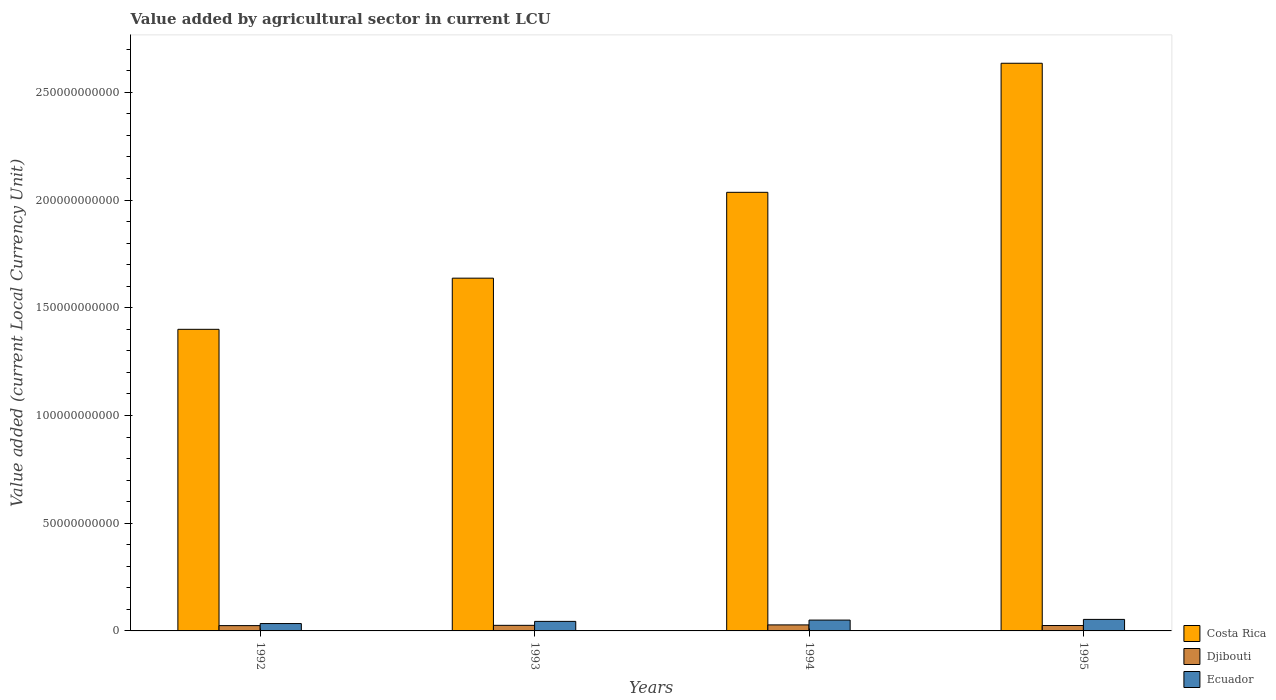Are the number of bars per tick equal to the number of legend labels?
Make the answer very short. Yes. How many bars are there on the 4th tick from the left?
Give a very brief answer. 3. How many bars are there on the 3rd tick from the right?
Provide a succinct answer. 3. What is the label of the 4th group of bars from the left?
Your answer should be very brief. 1995. In how many cases, is the number of bars for a given year not equal to the number of legend labels?
Provide a short and direct response. 0. What is the value added by agricultural sector in Costa Rica in 1994?
Provide a short and direct response. 2.04e+11. Across all years, what is the maximum value added by agricultural sector in Costa Rica?
Make the answer very short. 2.63e+11. Across all years, what is the minimum value added by agricultural sector in Djibouti?
Provide a short and direct response. 2.46e+09. What is the total value added by agricultural sector in Ecuador in the graph?
Make the answer very short. 1.82e+1. What is the difference between the value added by agricultural sector in Costa Rica in 1993 and that in 1995?
Your response must be concise. -9.97e+1. What is the difference between the value added by agricultural sector in Ecuador in 1994 and the value added by agricultural sector in Djibouti in 1995?
Give a very brief answer. 2.52e+09. What is the average value added by agricultural sector in Ecuador per year?
Provide a succinct answer. 4.56e+09. In the year 1993, what is the difference between the value added by agricultural sector in Ecuador and value added by agricultural sector in Djibouti?
Your answer should be compact. 1.83e+09. In how many years, is the value added by agricultural sector in Ecuador greater than 10000000000 LCU?
Offer a terse response. 0. What is the ratio of the value added by agricultural sector in Ecuador in 1993 to that in 1995?
Ensure brevity in your answer.  0.83. Is the difference between the value added by agricultural sector in Ecuador in 1993 and 1995 greater than the difference between the value added by agricultural sector in Djibouti in 1993 and 1995?
Your response must be concise. No. What is the difference between the highest and the second highest value added by agricultural sector in Djibouti?
Offer a very short reply. 1.97e+08. What is the difference between the highest and the lowest value added by agricultural sector in Djibouti?
Give a very brief answer. 3.34e+08. In how many years, is the value added by agricultural sector in Ecuador greater than the average value added by agricultural sector in Ecuador taken over all years?
Give a very brief answer. 2. Is the sum of the value added by agricultural sector in Costa Rica in 1993 and 1994 greater than the maximum value added by agricultural sector in Djibouti across all years?
Your answer should be very brief. Yes. What does the 2nd bar from the left in 1995 represents?
Your response must be concise. Djibouti. What does the 2nd bar from the right in 1994 represents?
Offer a very short reply. Djibouti. Does the graph contain any zero values?
Your response must be concise. No. Does the graph contain grids?
Provide a short and direct response. No. Where does the legend appear in the graph?
Your answer should be very brief. Bottom right. What is the title of the graph?
Offer a terse response. Value added by agricultural sector in current LCU. Does "Tanzania" appear as one of the legend labels in the graph?
Make the answer very short. No. What is the label or title of the X-axis?
Your response must be concise. Years. What is the label or title of the Y-axis?
Make the answer very short. Value added (current Local Currency Unit). What is the Value added (current Local Currency Unit) in Costa Rica in 1992?
Offer a terse response. 1.40e+11. What is the Value added (current Local Currency Unit) in Djibouti in 1992?
Offer a terse response. 2.46e+09. What is the Value added (current Local Currency Unit) in Ecuador in 1992?
Ensure brevity in your answer.  3.42e+09. What is the Value added (current Local Currency Unit) in Costa Rica in 1993?
Make the answer very short. 1.64e+11. What is the Value added (current Local Currency Unit) in Djibouti in 1993?
Your response must be concise. 2.60e+09. What is the Value added (current Local Currency Unit) in Ecuador in 1993?
Keep it short and to the point. 4.43e+09. What is the Value added (current Local Currency Unit) in Costa Rica in 1994?
Offer a terse response. 2.04e+11. What is the Value added (current Local Currency Unit) in Djibouti in 1994?
Make the answer very short. 2.79e+09. What is the Value added (current Local Currency Unit) in Ecuador in 1994?
Make the answer very short. 5.03e+09. What is the Value added (current Local Currency Unit) of Costa Rica in 1995?
Provide a succinct answer. 2.63e+11. What is the Value added (current Local Currency Unit) of Djibouti in 1995?
Provide a short and direct response. 2.51e+09. What is the Value added (current Local Currency Unit) in Ecuador in 1995?
Your response must be concise. 5.35e+09. Across all years, what is the maximum Value added (current Local Currency Unit) of Costa Rica?
Your answer should be very brief. 2.63e+11. Across all years, what is the maximum Value added (current Local Currency Unit) in Djibouti?
Keep it short and to the point. 2.79e+09. Across all years, what is the maximum Value added (current Local Currency Unit) in Ecuador?
Offer a terse response. 5.35e+09. Across all years, what is the minimum Value added (current Local Currency Unit) in Costa Rica?
Your answer should be compact. 1.40e+11. Across all years, what is the minimum Value added (current Local Currency Unit) in Djibouti?
Provide a short and direct response. 2.46e+09. Across all years, what is the minimum Value added (current Local Currency Unit) in Ecuador?
Provide a succinct answer. 3.42e+09. What is the total Value added (current Local Currency Unit) of Costa Rica in the graph?
Your response must be concise. 7.71e+11. What is the total Value added (current Local Currency Unit) of Djibouti in the graph?
Provide a short and direct response. 1.04e+1. What is the total Value added (current Local Currency Unit) of Ecuador in the graph?
Your answer should be compact. 1.82e+1. What is the difference between the Value added (current Local Currency Unit) in Costa Rica in 1992 and that in 1993?
Your response must be concise. -2.37e+1. What is the difference between the Value added (current Local Currency Unit) in Djibouti in 1992 and that in 1993?
Offer a very short reply. -1.36e+08. What is the difference between the Value added (current Local Currency Unit) in Ecuador in 1992 and that in 1993?
Provide a short and direct response. -1.01e+09. What is the difference between the Value added (current Local Currency Unit) of Costa Rica in 1992 and that in 1994?
Your response must be concise. -6.36e+1. What is the difference between the Value added (current Local Currency Unit) in Djibouti in 1992 and that in 1994?
Your answer should be compact. -3.34e+08. What is the difference between the Value added (current Local Currency Unit) of Ecuador in 1992 and that in 1994?
Ensure brevity in your answer.  -1.60e+09. What is the difference between the Value added (current Local Currency Unit) in Costa Rica in 1992 and that in 1995?
Provide a succinct answer. -1.23e+11. What is the difference between the Value added (current Local Currency Unit) of Djibouti in 1992 and that in 1995?
Provide a short and direct response. -4.76e+07. What is the difference between the Value added (current Local Currency Unit) of Ecuador in 1992 and that in 1995?
Ensure brevity in your answer.  -1.93e+09. What is the difference between the Value added (current Local Currency Unit) of Costa Rica in 1993 and that in 1994?
Provide a short and direct response. -3.98e+1. What is the difference between the Value added (current Local Currency Unit) in Djibouti in 1993 and that in 1994?
Your answer should be compact. -1.97e+08. What is the difference between the Value added (current Local Currency Unit) of Ecuador in 1993 and that in 1994?
Ensure brevity in your answer.  -5.96e+08. What is the difference between the Value added (current Local Currency Unit) in Costa Rica in 1993 and that in 1995?
Provide a short and direct response. -9.97e+1. What is the difference between the Value added (current Local Currency Unit) of Djibouti in 1993 and that in 1995?
Offer a terse response. 8.87e+07. What is the difference between the Value added (current Local Currency Unit) in Ecuador in 1993 and that in 1995?
Your answer should be very brief. -9.21e+08. What is the difference between the Value added (current Local Currency Unit) of Costa Rica in 1994 and that in 1995?
Your answer should be very brief. -5.99e+1. What is the difference between the Value added (current Local Currency Unit) of Djibouti in 1994 and that in 1995?
Provide a short and direct response. 2.86e+08. What is the difference between the Value added (current Local Currency Unit) in Ecuador in 1994 and that in 1995?
Your response must be concise. -3.25e+08. What is the difference between the Value added (current Local Currency Unit) in Costa Rica in 1992 and the Value added (current Local Currency Unit) in Djibouti in 1993?
Give a very brief answer. 1.37e+11. What is the difference between the Value added (current Local Currency Unit) of Costa Rica in 1992 and the Value added (current Local Currency Unit) of Ecuador in 1993?
Offer a very short reply. 1.36e+11. What is the difference between the Value added (current Local Currency Unit) of Djibouti in 1992 and the Value added (current Local Currency Unit) of Ecuador in 1993?
Your response must be concise. -1.97e+09. What is the difference between the Value added (current Local Currency Unit) in Costa Rica in 1992 and the Value added (current Local Currency Unit) in Djibouti in 1994?
Your response must be concise. 1.37e+11. What is the difference between the Value added (current Local Currency Unit) in Costa Rica in 1992 and the Value added (current Local Currency Unit) in Ecuador in 1994?
Your response must be concise. 1.35e+11. What is the difference between the Value added (current Local Currency Unit) in Djibouti in 1992 and the Value added (current Local Currency Unit) in Ecuador in 1994?
Your response must be concise. -2.57e+09. What is the difference between the Value added (current Local Currency Unit) of Costa Rica in 1992 and the Value added (current Local Currency Unit) of Djibouti in 1995?
Your answer should be compact. 1.37e+11. What is the difference between the Value added (current Local Currency Unit) of Costa Rica in 1992 and the Value added (current Local Currency Unit) of Ecuador in 1995?
Offer a terse response. 1.35e+11. What is the difference between the Value added (current Local Currency Unit) of Djibouti in 1992 and the Value added (current Local Currency Unit) of Ecuador in 1995?
Make the answer very short. -2.89e+09. What is the difference between the Value added (current Local Currency Unit) in Costa Rica in 1993 and the Value added (current Local Currency Unit) in Djibouti in 1994?
Give a very brief answer. 1.61e+11. What is the difference between the Value added (current Local Currency Unit) of Costa Rica in 1993 and the Value added (current Local Currency Unit) of Ecuador in 1994?
Offer a terse response. 1.59e+11. What is the difference between the Value added (current Local Currency Unit) of Djibouti in 1993 and the Value added (current Local Currency Unit) of Ecuador in 1994?
Give a very brief answer. -2.43e+09. What is the difference between the Value added (current Local Currency Unit) of Costa Rica in 1993 and the Value added (current Local Currency Unit) of Djibouti in 1995?
Ensure brevity in your answer.  1.61e+11. What is the difference between the Value added (current Local Currency Unit) in Costa Rica in 1993 and the Value added (current Local Currency Unit) in Ecuador in 1995?
Offer a terse response. 1.58e+11. What is the difference between the Value added (current Local Currency Unit) in Djibouti in 1993 and the Value added (current Local Currency Unit) in Ecuador in 1995?
Provide a succinct answer. -2.76e+09. What is the difference between the Value added (current Local Currency Unit) of Costa Rica in 1994 and the Value added (current Local Currency Unit) of Djibouti in 1995?
Offer a terse response. 2.01e+11. What is the difference between the Value added (current Local Currency Unit) of Costa Rica in 1994 and the Value added (current Local Currency Unit) of Ecuador in 1995?
Provide a short and direct response. 1.98e+11. What is the difference between the Value added (current Local Currency Unit) in Djibouti in 1994 and the Value added (current Local Currency Unit) in Ecuador in 1995?
Offer a terse response. -2.56e+09. What is the average Value added (current Local Currency Unit) in Costa Rica per year?
Provide a short and direct response. 1.93e+11. What is the average Value added (current Local Currency Unit) in Djibouti per year?
Your answer should be very brief. 2.59e+09. What is the average Value added (current Local Currency Unit) of Ecuador per year?
Give a very brief answer. 4.56e+09. In the year 1992, what is the difference between the Value added (current Local Currency Unit) of Costa Rica and Value added (current Local Currency Unit) of Djibouti?
Your answer should be compact. 1.38e+11. In the year 1992, what is the difference between the Value added (current Local Currency Unit) of Costa Rica and Value added (current Local Currency Unit) of Ecuador?
Offer a very short reply. 1.37e+11. In the year 1992, what is the difference between the Value added (current Local Currency Unit) in Djibouti and Value added (current Local Currency Unit) in Ecuador?
Provide a succinct answer. -9.63e+08. In the year 1993, what is the difference between the Value added (current Local Currency Unit) in Costa Rica and Value added (current Local Currency Unit) in Djibouti?
Make the answer very short. 1.61e+11. In the year 1993, what is the difference between the Value added (current Local Currency Unit) of Costa Rica and Value added (current Local Currency Unit) of Ecuador?
Your answer should be compact. 1.59e+11. In the year 1993, what is the difference between the Value added (current Local Currency Unit) of Djibouti and Value added (current Local Currency Unit) of Ecuador?
Offer a very short reply. -1.83e+09. In the year 1994, what is the difference between the Value added (current Local Currency Unit) in Costa Rica and Value added (current Local Currency Unit) in Djibouti?
Provide a short and direct response. 2.01e+11. In the year 1994, what is the difference between the Value added (current Local Currency Unit) of Costa Rica and Value added (current Local Currency Unit) of Ecuador?
Your response must be concise. 1.99e+11. In the year 1994, what is the difference between the Value added (current Local Currency Unit) in Djibouti and Value added (current Local Currency Unit) in Ecuador?
Your answer should be compact. -2.23e+09. In the year 1995, what is the difference between the Value added (current Local Currency Unit) of Costa Rica and Value added (current Local Currency Unit) of Djibouti?
Your answer should be compact. 2.61e+11. In the year 1995, what is the difference between the Value added (current Local Currency Unit) of Costa Rica and Value added (current Local Currency Unit) of Ecuador?
Your response must be concise. 2.58e+11. In the year 1995, what is the difference between the Value added (current Local Currency Unit) of Djibouti and Value added (current Local Currency Unit) of Ecuador?
Your answer should be compact. -2.84e+09. What is the ratio of the Value added (current Local Currency Unit) of Costa Rica in 1992 to that in 1993?
Offer a very short reply. 0.85. What is the ratio of the Value added (current Local Currency Unit) of Djibouti in 1992 to that in 1993?
Provide a short and direct response. 0.95. What is the ratio of the Value added (current Local Currency Unit) of Ecuador in 1992 to that in 1993?
Your response must be concise. 0.77. What is the ratio of the Value added (current Local Currency Unit) of Costa Rica in 1992 to that in 1994?
Offer a very short reply. 0.69. What is the ratio of the Value added (current Local Currency Unit) of Djibouti in 1992 to that in 1994?
Make the answer very short. 0.88. What is the ratio of the Value added (current Local Currency Unit) in Ecuador in 1992 to that in 1994?
Your answer should be very brief. 0.68. What is the ratio of the Value added (current Local Currency Unit) in Costa Rica in 1992 to that in 1995?
Provide a succinct answer. 0.53. What is the ratio of the Value added (current Local Currency Unit) in Ecuador in 1992 to that in 1995?
Keep it short and to the point. 0.64. What is the ratio of the Value added (current Local Currency Unit) in Costa Rica in 1993 to that in 1994?
Provide a short and direct response. 0.8. What is the ratio of the Value added (current Local Currency Unit) of Djibouti in 1993 to that in 1994?
Make the answer very short. 0.93. What is the ratio of the Value added (current Local Currency Unit) of Ecuador in 1993 to that in 1994?
Your answer should be compact. 0.88. What is the ratio of the Value added (current Local Currency Unit) in Costa Rica in 1993 to that in 1995?
Provide a succinct answer. 0.62. What is the ratio of the Value added (current Local Currency Unit) in Djibouti in 1993 to that in 1995?
Provide a succinct answer. 1.04. What is the ratio of the Value added (current Local Currency Unit) of Ecuador in 1993 to that in 1995?
Offer a terse response. 0.83. What is the ratio of the Value added (current Local Currency Unit) of Costa Rica in 1994 to that in 1995?
Your response must be concise. 0.77. What is the ratio of the Value added (current Local Currency Unit) of Djibouti in 1994 to that in 1995?
Offer a very short reply. 1.11. What is the ratio of the Value added (current Local Currency Unit) of Ecuador in 1994 to that in 1995?
Your answer should be compact. 0.94. What is the difference between the highest and the second highest Value added (current Local Currency Unit) in Costa Rica?
Keep it short and to the point. 5.99e+1. What is the difference between the highest and the second highest Value added (current Local Currency Unit) in Djibouti?
Keep it short and to the point. 1.97e+08. What is the difference between the highest and the second highest Value added (current Local Currency Unit) of Ecuador?
Keep it short and to the point. 3.25e+08. What is the difference between the highest and the lowest Value added (current Local Currency Unit) of Costa Rica?
Provide a succinct answer. 1.23e+11. What is the difference between the highest and the lowest Value added (current Local Currency Unit) of Djibouti?
Ensure brevity in your answer.  3.34e+08. What is the difference between the highest and the lowest Value added (current Local Currency Unit) in Ecuador?
Offer a very short reply. 1.93e+09. 